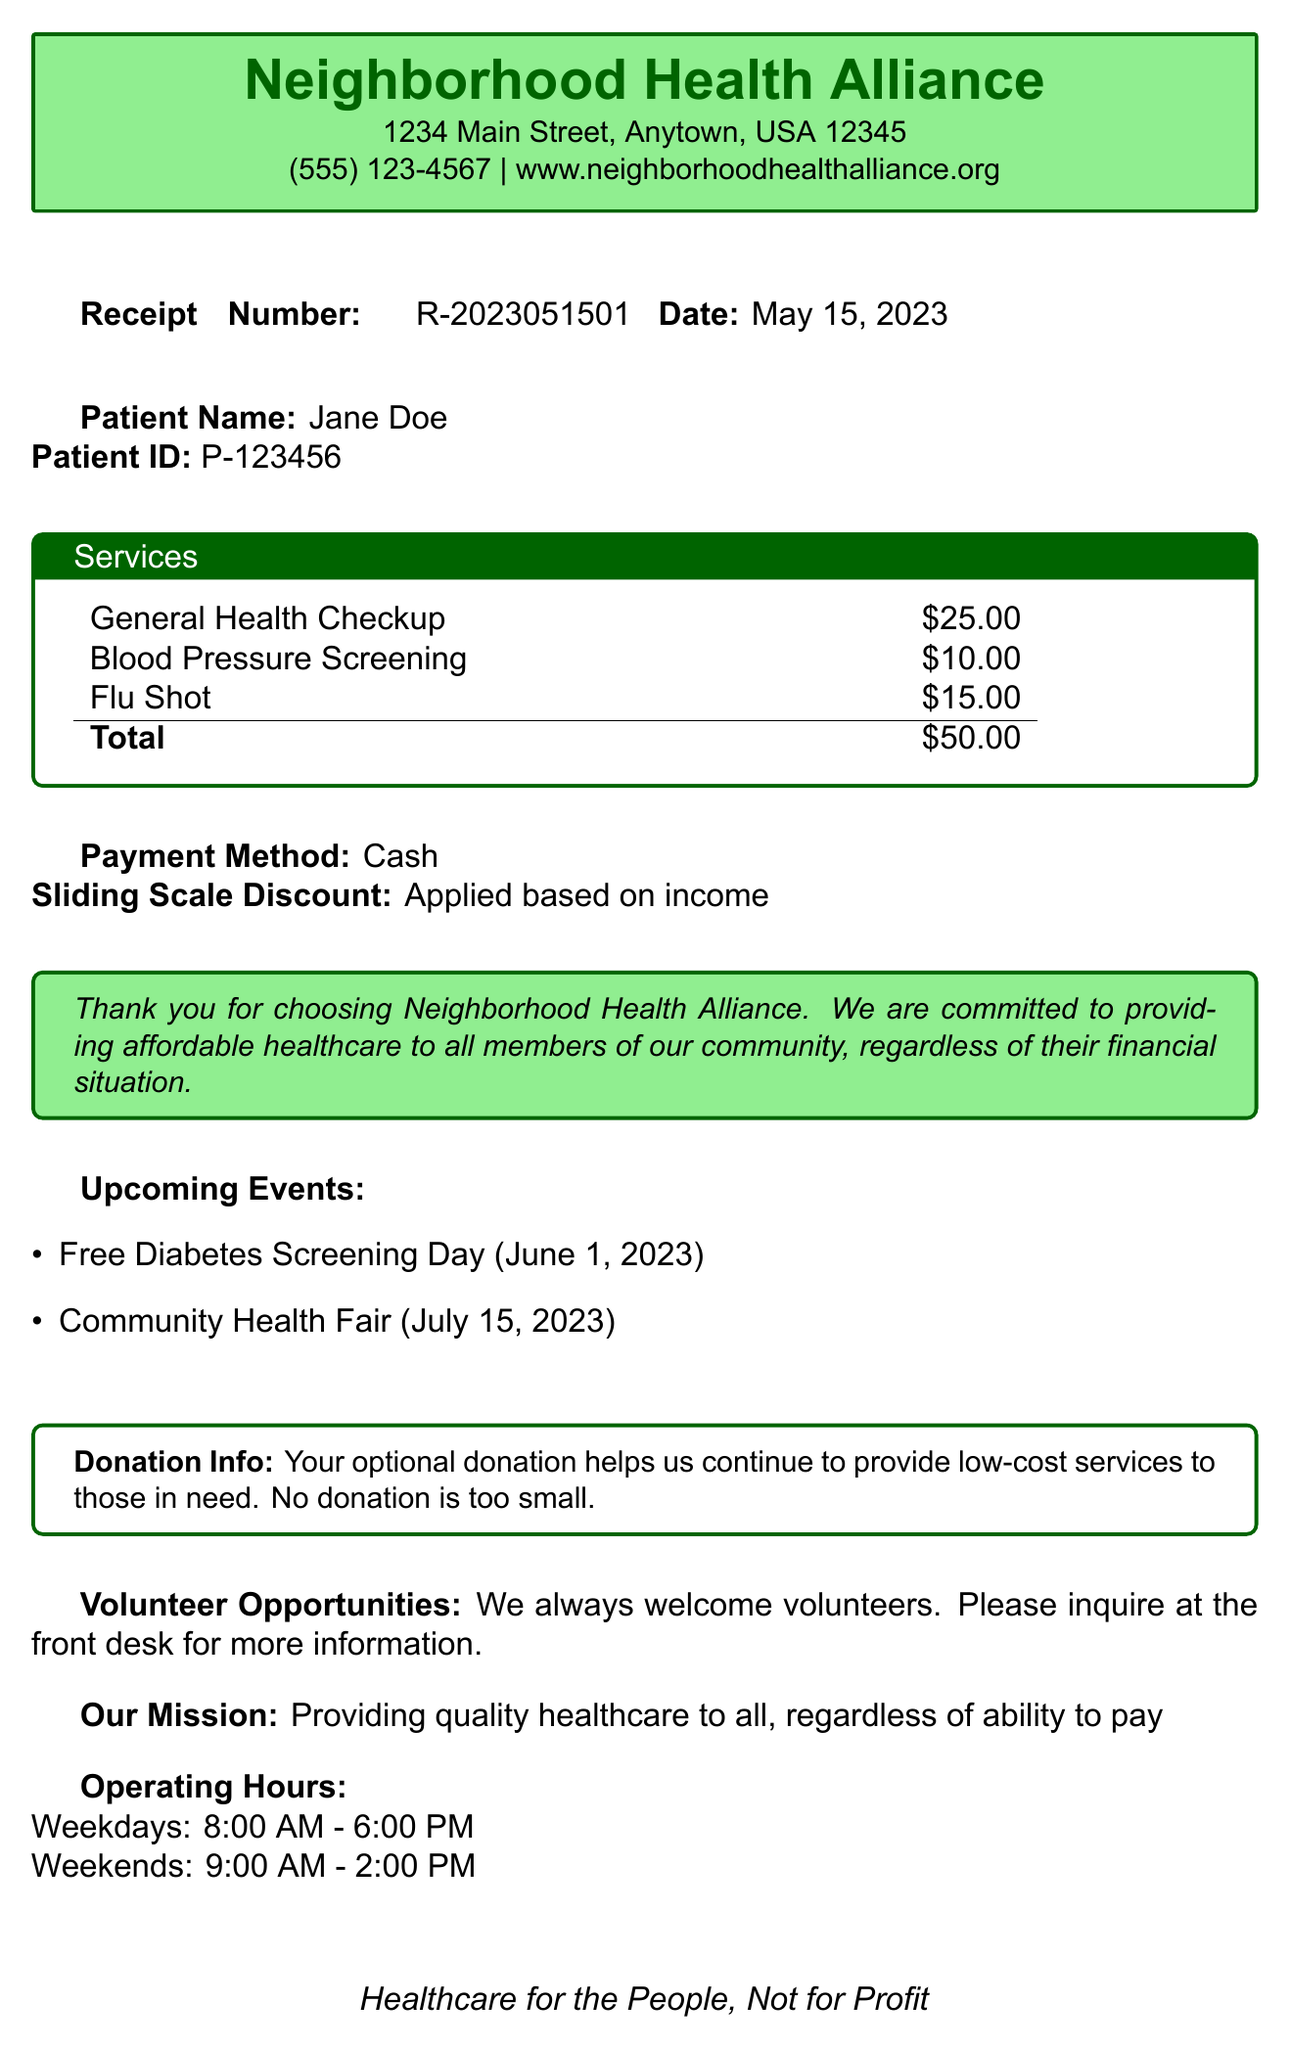What is the clinic's name? The clinic's name is prominently displayed at the top of the document.
Answer: Neighborhood Health Alliance What is the total cost of services? The total cost is calculated by adding the costs of all services listed in the document.
Answer: $50.00 When is the Free Diabetes Screening Day? The date for the Free Diabetes Screening Day is mentioned in the upcoming events section of the document.
Answer: June 1, 2023 What payment method was used? The payment method is specified directly under the total cost in the document.
Answer: Cash How many services are listed in the receipt? The number of services can be counted from the services section of the document.
Answer: 3 What is the mission statement of the clinic? The mission statement is explicitly stated in the document.
Answer: Providing quality healthcare to all, regardless of ability to pay Is there an optional donation mentioned? The document indicates whether donations are optional and provides information about it.
Answer: Yes What are the operating hours on weekends? The operating hours specifically listed for weekends provide this information in the document.
Answer: 9:00 AM - 2:00 PM What type of organization provides funding? The funding sources are listed, which indicates the type of organization.
Answer: Non-profit organizations 